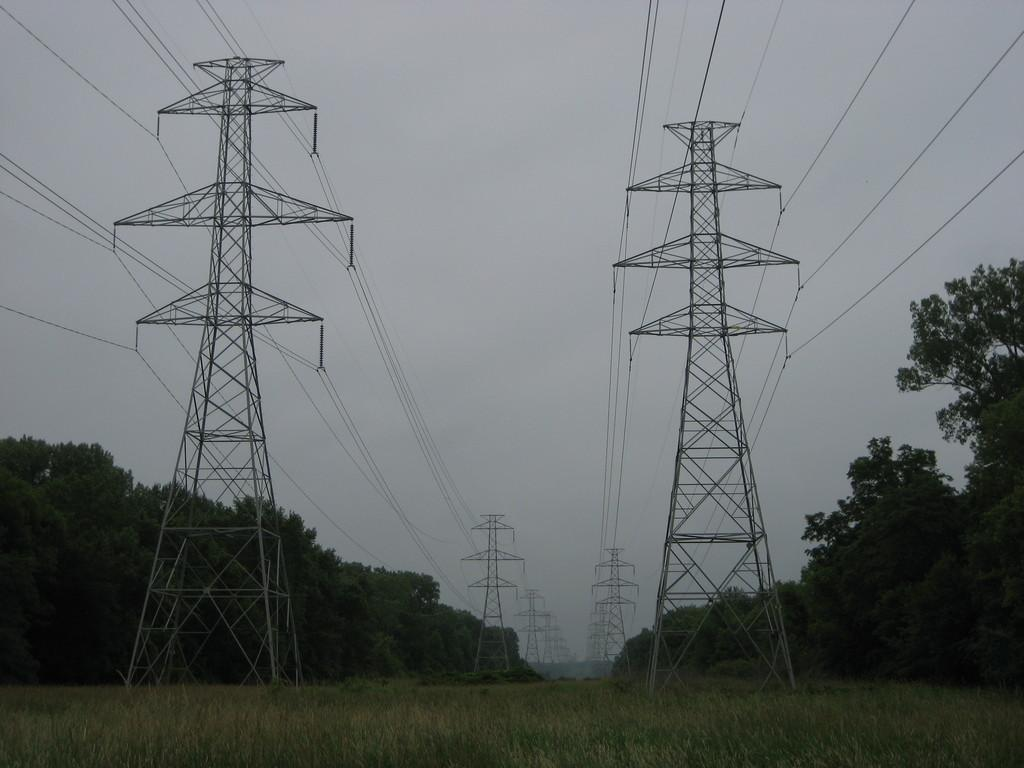What structures are present in the image? There are towers with wires in the image. What type of vegetation is visible near the towers? There are many trees to the side of the towers. What can be seen in the background of the image? The sky is visible in the background of the image. What type of roof can be seen on the towers in the image? The image does not show any roofs on the towers, as they are structures with wires. 